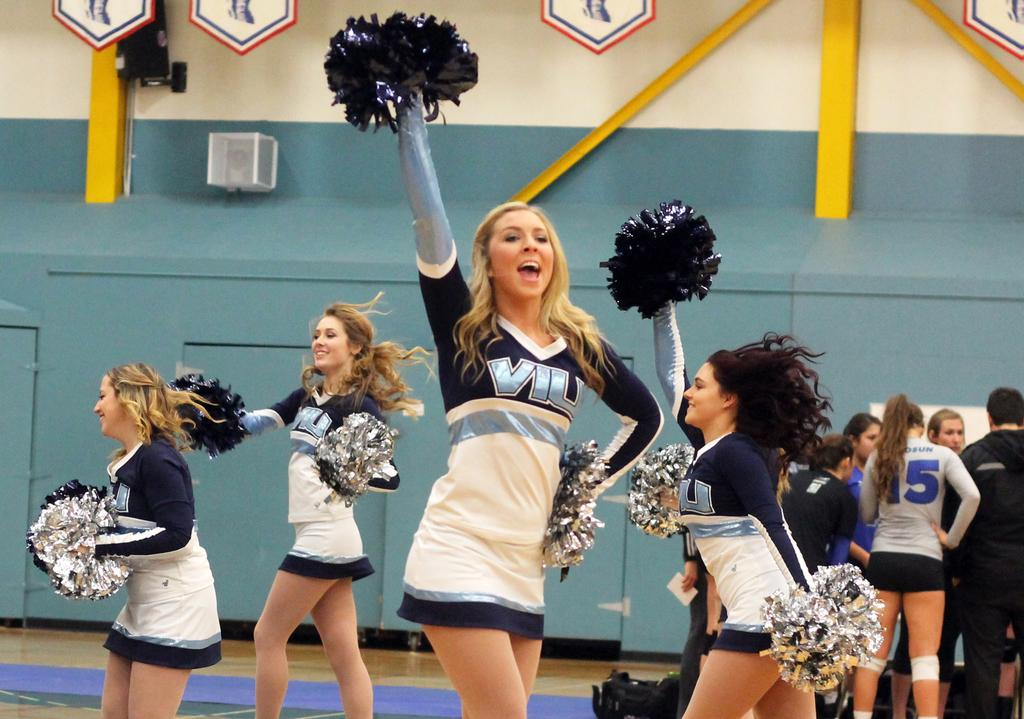<image>
Describe the image concisely. Cheerleaders wear uniforms with the initials "VIU" on the front. 